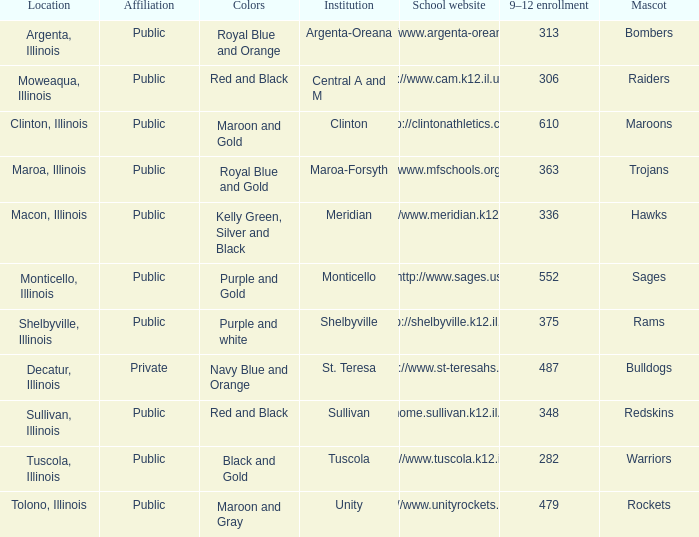What are the team shades from tolono, illinois? Maroon and Gray. 